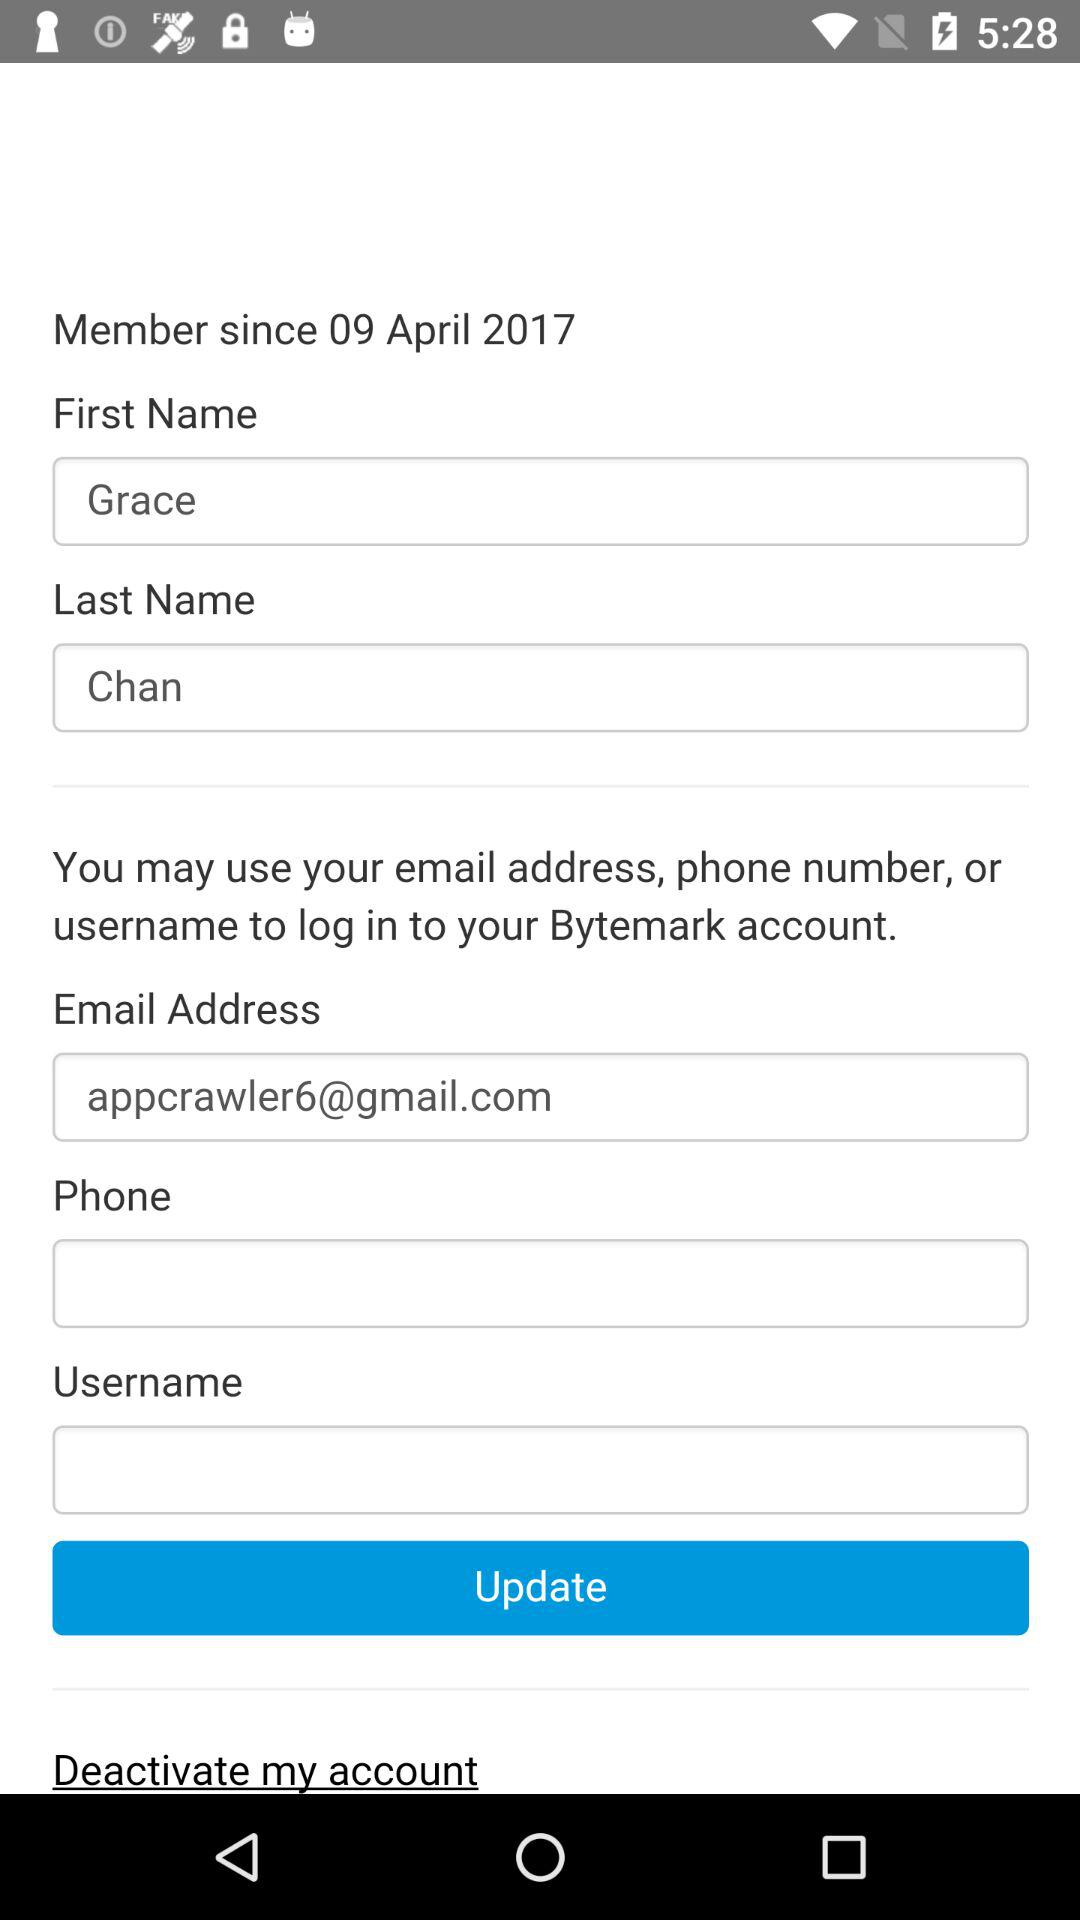What is the last name of the user? The last name of the user is Chan. 